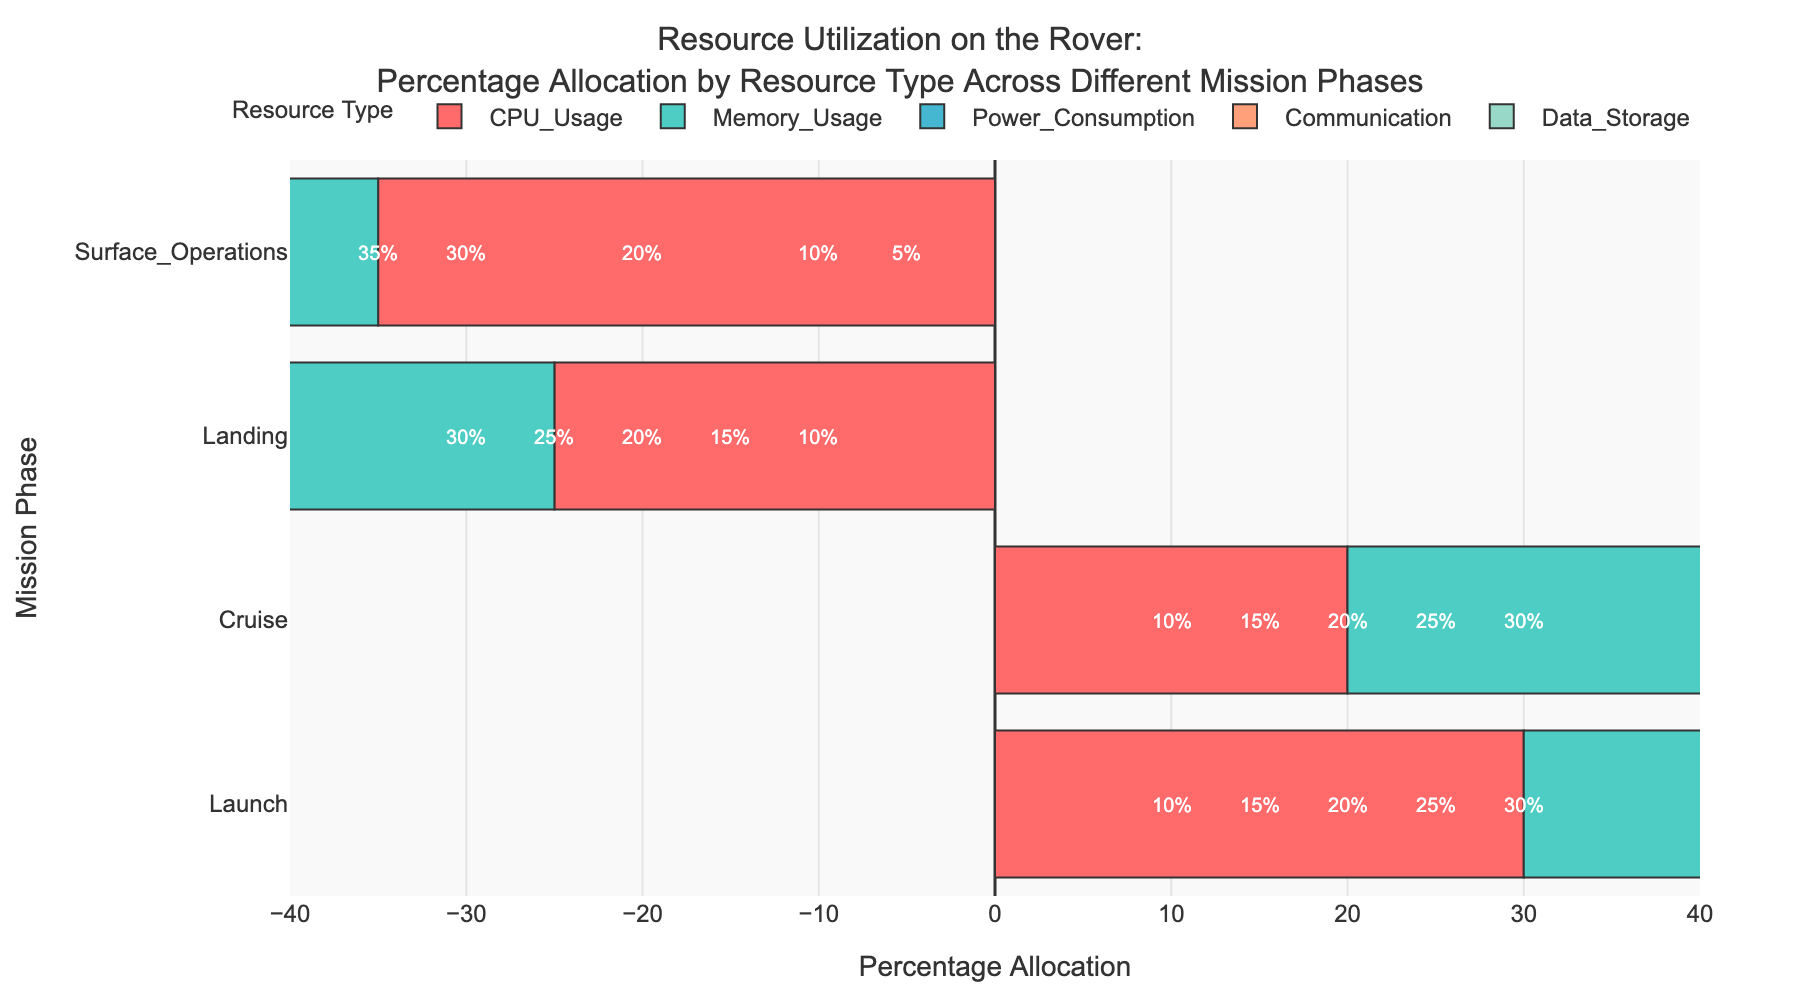What is the total percentage allocation of 'CPU Usage' across all mission phases? Sum up all the percentage values for 'CPU Usage' across Launch (30%), Cruise (20%), Landing (25%), and Surface Operations (35%). 30 + 20 + 25 + 35 = 110
Answer: 110% Which mission phase has the highest memory usage? Look at the 'Memory Usage' allocations across all mission phases and identify the highest value. Launch (25%), Cruise (30%), Landing (20%), Surface Operations (30%). The highest values are in Cruise and Surface Operations, both with 30%.
Answer: Cruise and Surface Operations In which mission phase is power consumption the greatest? Check the 'Power Consumption' bar segments for each mission phase and pick out the maximum value. Launch (20%), Cruise (15%), Landing (30%), Surface Operations (20%). The highest value is during Landing at 30%.
Answer: Landing What is the difference in communication resource allocation between Cruise and Surface Operations? Find the 'Communication' percentage allocation for both Cruise (25%) and Surface Operations (10%), then subtract the smaller from the larger value. 25 - 10 = 15
Answer: 15% Which resources have equal percentage allocation during the Launch phase? Find all resources during the Launch phase and determine which ones have the same percentage. 'Memory Usage' (25%) and 'Communication' (15%). 'Data Storage' is unique (10%). No two resources have equal allocation.
Answer: None Compare the resource allocation for communication during the Cruise and Landing phases. Which phase allocates a higher percentage? Look at the 'Communication' bar segments for Cruise (25%) and Landing (15%). The Cruise phase allocates a higher percentage than the Landing phase.
Answer: Cruise Calculate the average percentage allocation for power consumption across all mission phases. Sum the values of 'Power Consumption' for Launch (20%), Cruise (15%), Landing (30%), and Surface Operations (20%) and divide by 4. (20 + 15 + 30 + 20) / 4 = 21.25
Answer: 21.25% Which resource type has the lowest allocation during surface operations? Look at the resource allocations for Surface Operations and identify the one with the smallest value. CPU Usage (35%), Memory Usage (30%), Power Consumption (20%), Communication (10%), Data Storage (5%). The lowest value is 'Data Storage' at 5%.
Answer: Data Storage How does the allocation of data storage change from Cruise to Surface Operations? Compare the 'Data Storage' values between Cruise (10%) and Surface Operations (5%). The percentage decreases from 10% to 5%, a difference of 5%.
Answer: Decreases by 5% Determine the combined percentage allocations of 'Memory Usage' and 'Power Consumption' during the Landing phase. Add the percentage values of 'Memory Usage' (20%) and 'Power Consumption' (30%) during Landing. 20 + 30 = 50
Answer: 50% 